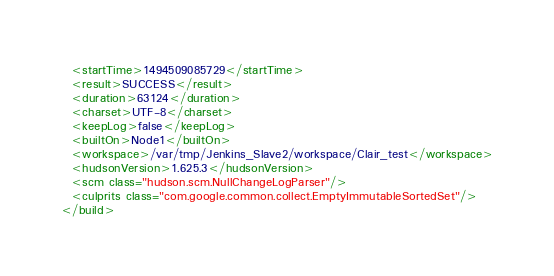<code> <loc_0><loc_0><loc_500><loc_500><_XML_>  <startTime>1494509085729</startTime>
  <result>SUCCESS</result>
  <duration>63124</duration>
  <charset>UTF-8</charset>
  <keepLog>false</keepLog>
  <builtOn>Node1</builtOn>
  <workspace>/var/tmp/Jenkins_Slave2/workspace/Clair_test</workspace>
  <hudsonVersion>1.625.3</hudsonVersion>
  <scm class="hudson.scm.NullChangeLogParser"/>
  <culprits class="com.google.common.collect.EmptyImmutableSortedSet"/>
</build></code> 